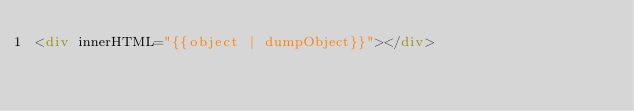<code> <loc_0><loc_0><loc_500><loc_500><_HTML_><div innerHTML="{{object | dumpObject}}"></div>
</code> 